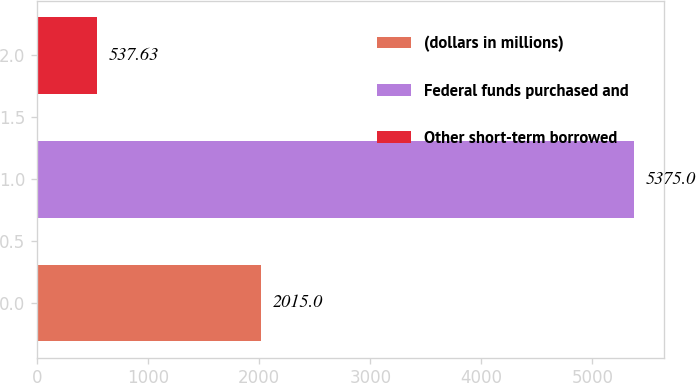Convert chart. <chart><loc_0><loc_0><loc_500><loc_500><bar_chart><fcel>(dollars in millions)<fcel>Federal funds purchased and<fcel>Other short-term borrowed<nl><fcel>2015<fcel>5375<fcel>537.63<nl></chart> 